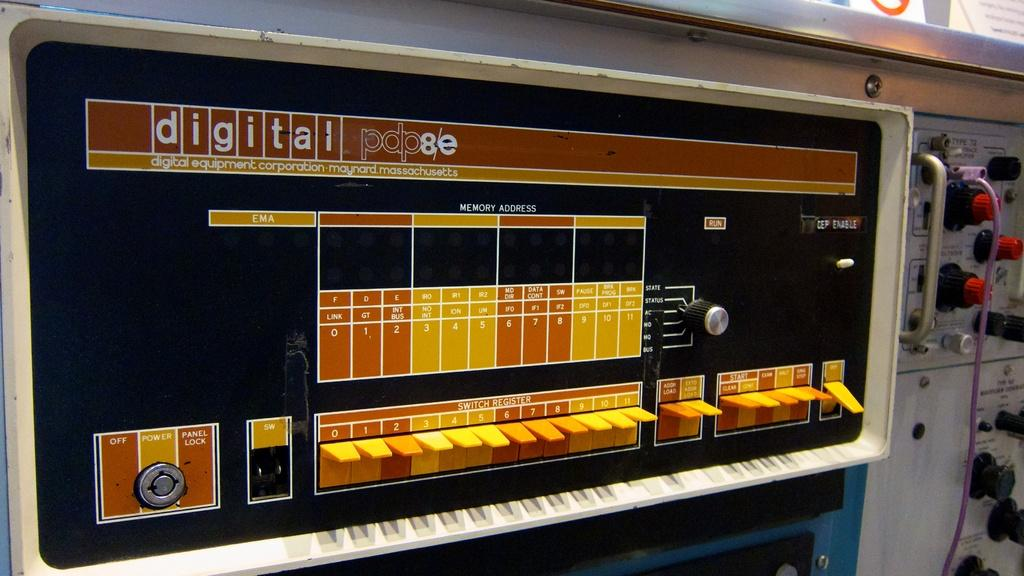What type of object is present in the image that is electronic? There is an electronic device in the image. What is connected to the electronic device in the image? There is a cable wire in the image. What can be seen in the image that is written or printed? There is text in the image. What type of meat is being served on the chin in the image? There is no meat or chin present in the image. 